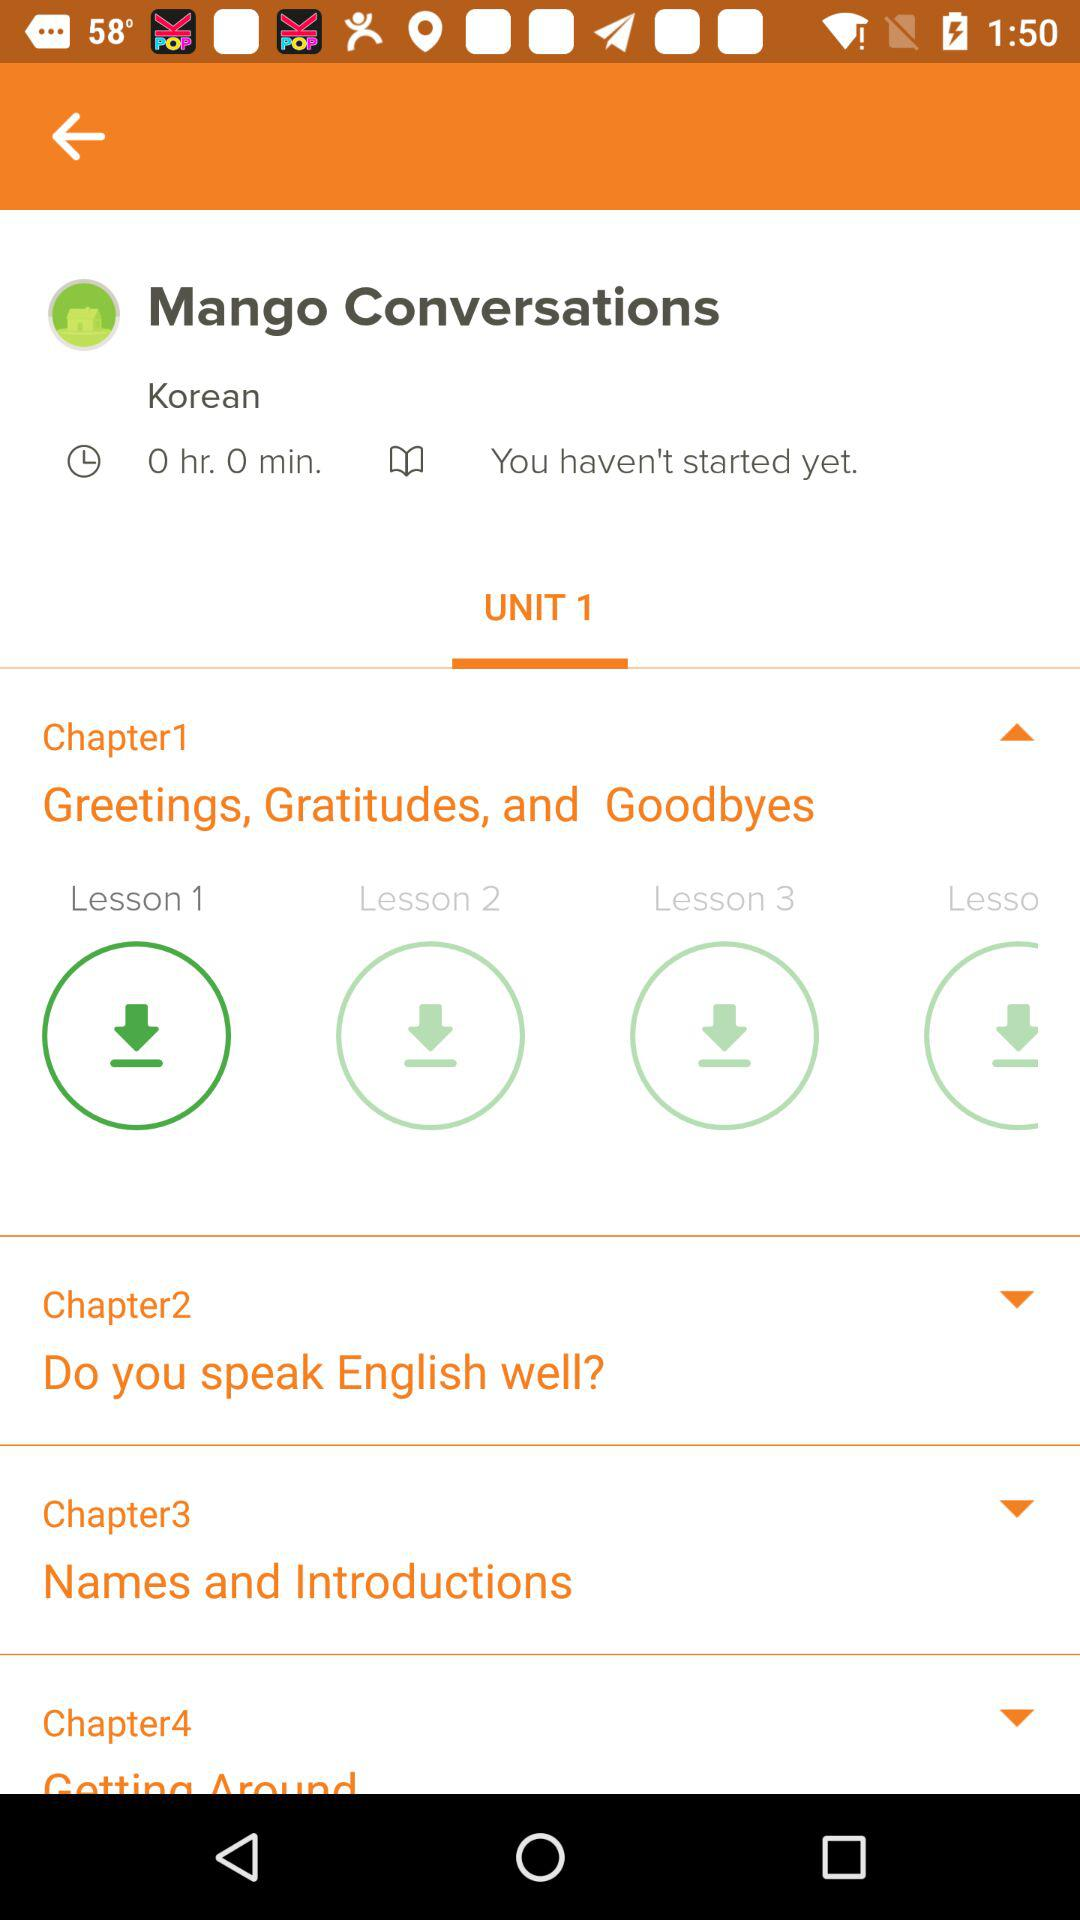How many chapters are there in this course?
Answer the question using a single word or phrase. 4 